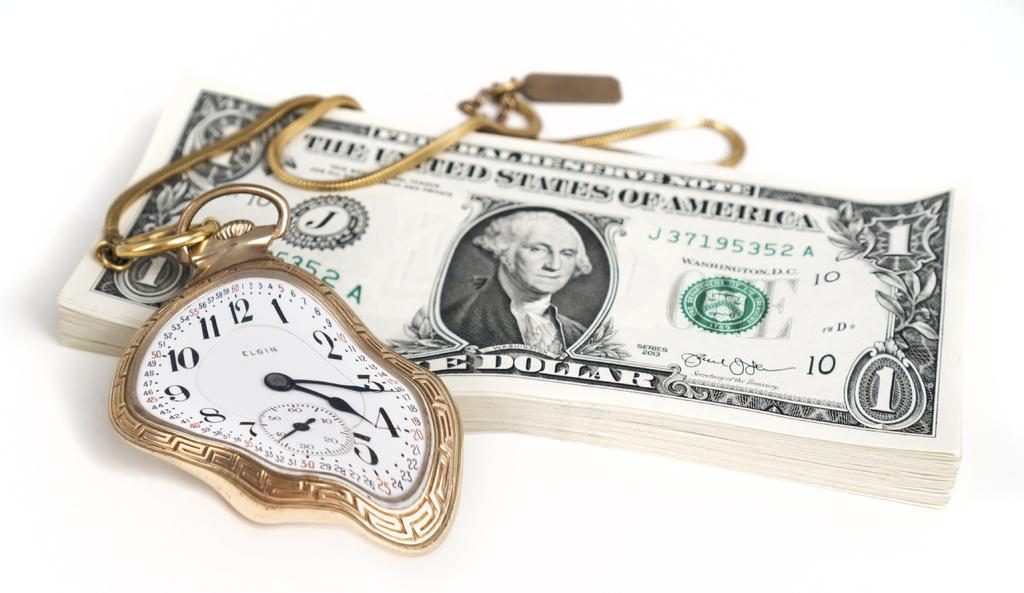<image>
Relay a brief, clear account of the picture shown. a odd shaped gold elgin watch on a one dollar bill 